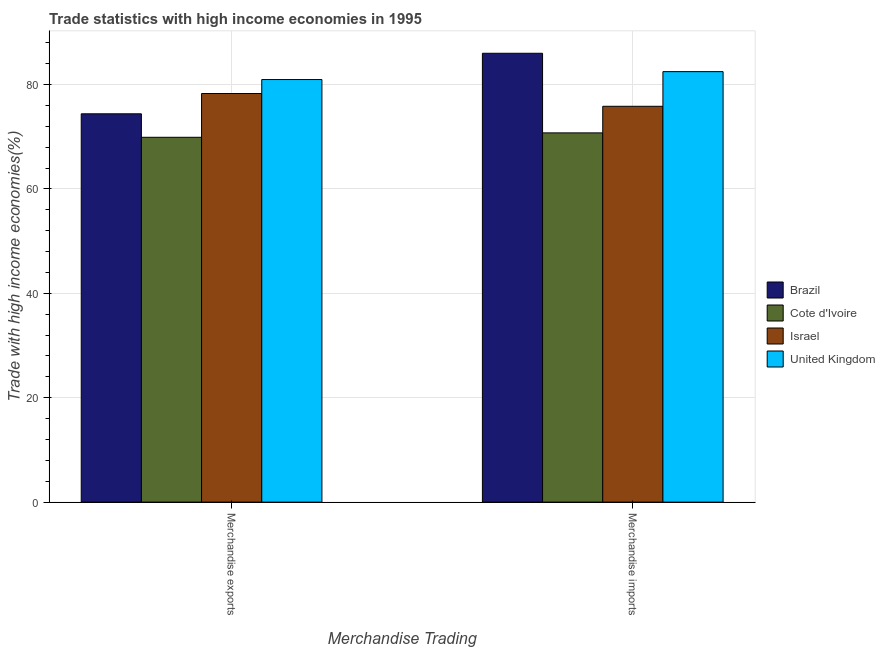How many different coloured bars are there?
Offer a very short reply. 4. How many bars are there on the 1st tick from the left?
Provide a short and direct response. 4. How many bars are there on the 1st tick from the right?
Provide a succinct answer. 4. What is the label of the 1st group of bars from the left?
Your answer should be very brief. Merchandise exports. What is the merchandise exports in United Kingdom?
Your answer should be compact. 80.94. Across all countries, what is the maximum merchandise exports?
Make the answer very short. 80.94. Across all countries, what is the minimum merchandise exports?
Make the answer very short. 69.88. In which country was the merchandise imports maximum?
Your answer should be compact. Brazil. In which country was the merchandise imports minimum?
Keep it short and to the point. Cote d'Ivoire. What is the total merchandise exports in the graph?
Your response must be concise. 303.48. What is the difference between the merchandise exports in United Kingdom and that in Israel?
Your response must be concise. 2.68. What is the difference between the merchandise exports in Israel and the merchandise imports in United Kingdom?
Your answer should be compact. -4.19. What is the average merchandise exports per country?
Keep it short and to the point. 75.87. What is the difference between the merchandise imports and merchandise exports in United Kingdom?
Keep it short and to the point. 1.51. What is the ratio of the merchandise imports in Brazil to that in Israel?
Your response must be concise. 1.13. In how many countries, is the merchandise imports greater than the average merchandise imports taken over all countries?
Your response must be concise. 2. What does the 3rd bar from the left in Merchandise imports represents?
Your response must be concise. Israel. What does the 2nd bar from the right in Merchandise exports represents?
Provide a short and direct response. Israel. Are the values on the major ticks of Y-axis written in scientific E-notation?
Your answer should be compact. No. Does the graph contain any zero values?
Offer a terse response. No. What is the title of the graph?
Give a very brief answer. Trade statistics with high income economies in 1995. Does "OECD members" appear as one of the legend labels in the graph?
Ensure brevity in your answer.  No. What is the label or title of the X-axis?
Your answer should be compact. Merchandise Trading. What is the label or title of the Y-axis?
Keep it short and to the point. Trade with high income economies(%). What is the Trade with high income economies(%) in Brazil in Merchandise exports?
Offer a terse response. 74.38. What is the Trade with high income economies(%) in Cote d'Ivoire in Merchandise exports?
Your response must be concise. 69.88. What is the Trade with high income economies(%) of Israel in Merchandise exports?
Provide a succinct answer. 78.27. What is the Trade with high income economies(%) of United Kingdom in Merchandise exports?
Make the answer very short. 80.94. What is the Trade with high income economies(%) in Brazil in Merchandise imports?
Your answer should be very brief. 85.98. What is the Trade with high income economies(%) in Cote d'Ivoire in Merchandise imports?
Your answer should be very brief. 70.73. What is the Trade with high income economies(%) of Israel in Merchandise imports?
Make the answer very short. 75.82. What is the Trade with high income economies(%) of United Kingdom in Merchandise imports?
Keep it short and to the point. 82.46. Across all Merchandise Trading, what is the maximum Trade with high income economies(%) of Brazil?
Offer a terse response. 85.98. Across all Merchandise Trading, what is the maximum Trade with high income economies(%) of Cote d'Ivoire?
Keep it short and to the point. 70.73. Across all Merchandise Trading, what is the maximum Trade with high income economies(%) of Israel?
Ensure brevity in your answer.  78.27. Across all Merchandise Trading, what is the maximum Trade with high income economies(%) of United Kingdom?
Give a very brief answer. 82.46. Across all Merchandise Trading, what is the minimum Trade with high income economies(%) of Brazil?
Provide a short and direct response. 74.38. Across all Merchandise Trading, what is the minimum Trade with high income economies(%) in Cote d'Ivoire?
Provide a succinct answer. 69.88. Across all Merchandise Trading, what is the minimum Trade with high income economies(%) of Israel?
Your response must be concise. 75.82. Across all Merchandise Trading, what is the minimum Trade with high income economies(%) of United Kingdom?
Your response must be concise. 80.94. What is the total Trade with high income economies(%) in Brazil in the graph?
Make the answer very short. 160.36. What is the total Trade with high income economies(%) of Cote d'Ivoire in the graph?
Your answer should be compact. 140.61. What is the total Trade with high income economies(%) in Israel in the graph?
Keep it short and to the point. 154.09. What is the total Trade with high income economies(%) of United Kingdom in the graph?
Provide a succinct answer. 163.4. What is the difference between the Trade with high income economies(%) in Brazil in Merchandise exports and that in Merchandise imports?
Your response must be concise. -11.6. What is the difference between the Trade with high income economies(%) of Cote d'Ivoire in Merchandise exports and that in Merchandise imports?
Give a very brief answer. -0.84. What is the difference between the Trade with high income economies(%) of Israel in Merchandise exports and that in Merchandise imports?
Offer a terse response. 2.45. What is the difference between the Trade with high income economies(%) in United Kingdom in Merchandise exports and that in Merchandise imports?
Provide a short and direct response. -1.51. What is the difference between the Trade with high income economies(%) of Brazil in Merchandise exports and the Trade with high income economies(%) of Cote d'Ivoire in Merchandise imports?
Your answer should be compact. 3.66. What is the difference between the Trade with high income economies(%) of Brazil in Merchandise exports and the Trade with high income economies(%) of Israel in Merchandise imports?
Your answer should be compact. -1.44. What is the difference between the Trade with high income economies(%) in Brazil in Merchandise exports and the Trade with high income economies(%) in United Kingdom in Merchandise imports?
Offer a terse response. -8.08. What is the difference between the Trade with high income economies(%) in Cote d'Ivoire in Merchandise exports and the Trade with high income economies(%) in Israel in Merchandise imports?
Make the answer very short. -5.94. What is the difference between the Trade with high income economies(%) of Cote d'Ivoire in Merchandise exports and the Trade with high income economies(%) of United Kingdom in Merchandise imports?
Provide a succinct answer. -12.57. What is the difference between the Trade with high income economies(%) in Israel in Merchandise exports and the Trade with high income economies(%) in United Kingdom in Merchandise imports?
Give a very brief answer. -4.19. What is the average Trade with high income economies(%) of Brazil per Merchandise Trading?
Provide a succinct answer. 80.18. What is the average Trade with high income economies(%) in Cote d'Ivoire per Merchandise Trading?
Ensure brevity in your answer.  70.31. What is the average Trade with high income economies(%) in Israel per Merchandise Trading?
Make the answer very short. 77.05. What is the average Trade with high income economies(%) in United Kingdom per Merchandise Trading?
Keep it short and to the point. 81.7. What is the difference between the Trade with high income economies(%) of Brazil and Trade with high income economies(%) of Cote d'Ivoire in Merchandise exports?
Ensure brevity in your answer.  4.5. What is the difference between the Trade with high income economies(%) of Brazil and Trade with high income economies(%) of Israel in Merchandise exports?
Your answer should be compact. -3.89. What is the difference between the Trade with high income economies(%) of Brazil and Trade with high income economies(%) of United Kingdom in Merchandise exports?
Ensure brevity in your answer.  -6.56. What is the difference between the Trade with high income economies(%) in Cote d'Ivoire and Trade with high income economies(%) in Israel in Merchandise exports?
Provide a succinct answer. -8.38. What is the difference between the Trade with high income economies(%) in Cote d'Ivoire and Trade with high income economies(%) in United Kingdom in Merchandise exports?
Make the answer very short. -11.06. What is the difference between the Trade with high income economies(%) of Israel and Trade with high income economies(%) of United Kingdom in Merchandise exports?
Offer a terse response. -2.68. What is the difference between the Trade with high income economies(%) in Brazil and Trade with high income economies(%) in Cote d'Ivoire in Merchandise imports?
Ensure brevity in your answer.  15.25. What is the difference between the Trade with high income economies(%) in Brazil and Trade with high income economies(%) in Israel in Merchandise imports?
Give a very brief answer. 10.15. What is the difference between the Trade with high income economies(%) of Brazil and Trade with high income economies(%) of United Kingdom in Merchandise imports?
Offer a terse response. 3.52. What is the difference between the Trade with high income economies(%) of Cote d'Ivoire and Trade with high income economies(%) of Israel in Merchandise imports?
Ensure brevity in your answer.  -5.1. What is the difference between the Trade with high income economies(%) in Cote d'Ivoire and Trade with high income economies(%) in United Kingdom in Merchandise imports?
Your answer should be very brief. -11.73. What is the difference between the Trade with high income economies(%) of Israel and Trade with high income economies(%) of United Kingdom in Merchandise imports?
Provide a succinct answer. -6.64. What is the ratio of the Trade with high income economies(%) in Brazil in Merchandise exports to that in Merchandise imports?
Your answer should be very brief. 0.87. What is the ratio of the Trade with high income economies(%) in Israel in Merchandise exports to that in Merchandise imports?
Your answer should be compact. 1.03. What is the ratio of the Trade with high income economies(%) in United Kingdom in Merchandise exports to that in Merchandise imports?
Give a very brief answer. 0.98. What is the difference between the highest and the second highest Trade with high income economies(%) in Brazil?
Ensure brevity in your answer.  11.6. What is the difference between the highest and the second highest Trade with high income economies(%) of Cote d'Ivoire?
Keep it short and to the point. 0.84. What is the difference between the highest and the second highest Trade with high income economies(%) in Israel?
Provide a short and direct response. 2.45. What is the difference between the highest and the second highest Trade with high income economies(%) in United Kingdom?
Provide a short and direct response. 1.51. What is the difference between the highest and the lowest Trade with high income economies(%) of Brazil?
Offer a very short reply. 11.6. What is the difference between the highest and the lowest Trade with high income economies(%) in Cote d'Ivoire?
Provide a short and direct response. 0.84. What is the difference between the highest and the lowest Trade with high income economies(%) in Israel?
Your answer should be compact. 2.45. What is the difference between the highest and the lowest Trade with high income economies(%) in United Kingdom?
Provide a short and direct response. 1.51. 